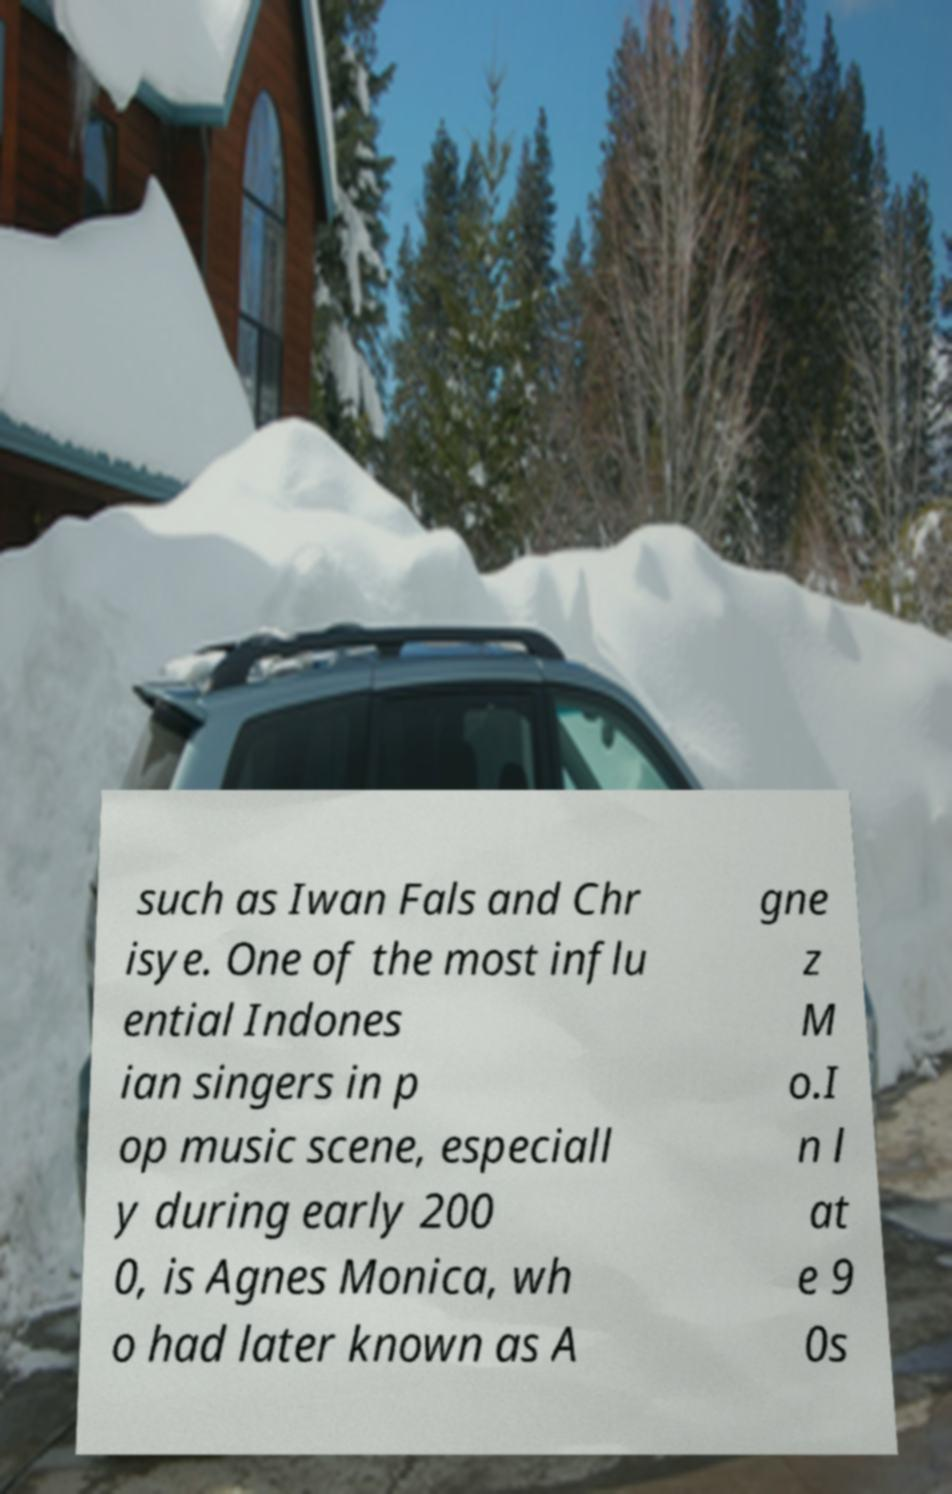Please identify and transcribe the text found in this image. such as Iwan Fals and Chr isye. One of the most influ ential Indones ian singers in p op music scene, especiall y during early 200 0, is Agnes Monica, wh o had later known as A gne z M o.I n l at e 9 0s 